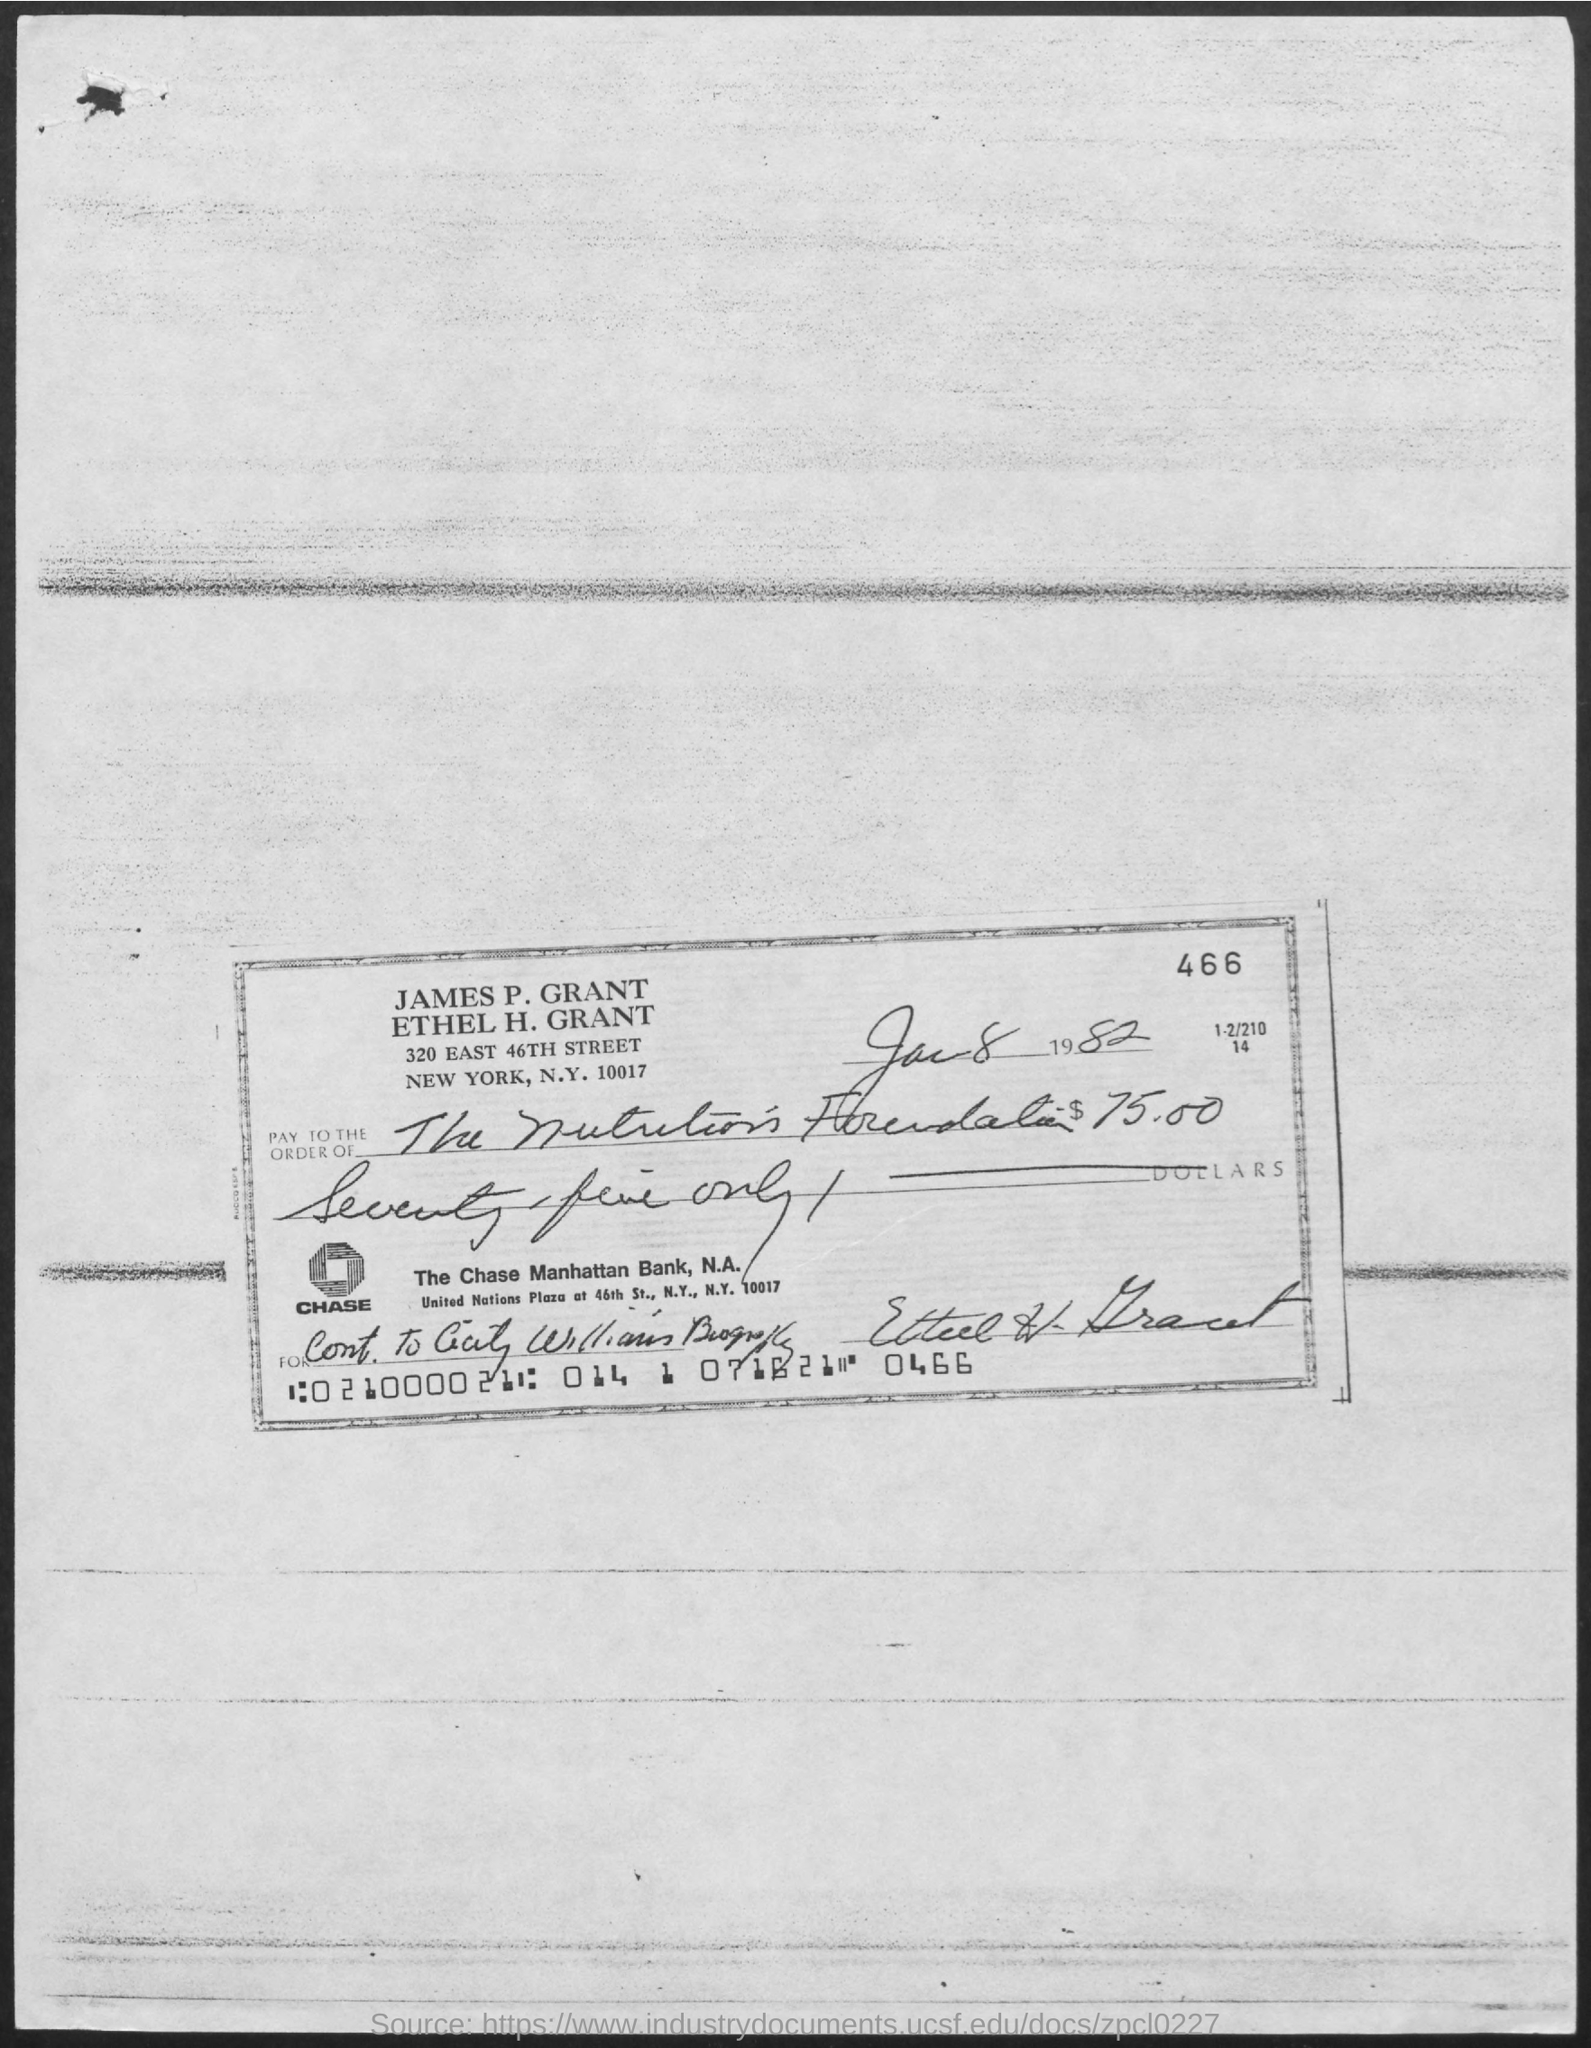Point out several critical features in this image. The cheque indicates that the date written is January 8, 1982. 